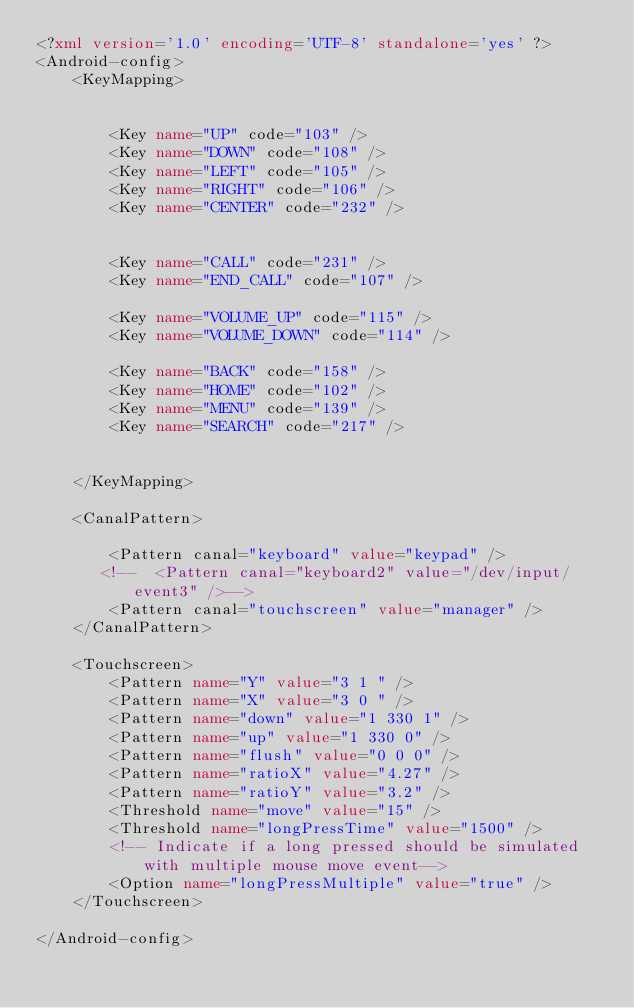<code> <loc_0><loc_0><loc_500><loc_500><_XML_><?xml version='1.0' encoding='UTF-8' standalone='yes' ?>
<Android-config>         
	<KeyMapping>
        
        
        <Key name="UP" code="103" />
        <Key name="DOWN" code="108" />
        <Key name="LEFT" code="105" />
        <Key name="RIGHT" code="106" />
        <Key name="CENTER" code="232" />
    
    
        <Key name="CALL" code="231" />
        <Key name="END_CALL" code="107" />
    
        <Key name="VOLUME_UP" code="115" />
        <Key name="VOLUME_DOWN" code="114" />
        
        <Key name="BACK" code="158" />
        <Key name="HOME" code="102" />
        <Key name="MENU" code="139" />
        <Key name="SEARCH" code="217" />
        
        
	</KeyMapping>

	<CanalPattern>

        <Pattern canal="keyboard" value="keypad" />
       <!--  <Pattern canal="keyboard2" value="/dev/input/event3" />-->
        <Pattern canal="touchscreen" value="manager" />
	</CanalPattern>
        
	<Touchscreen>
        <Pattern name="Y" value="3 1 " />
        <Pattern name="X" value="3 0 " />
        <Pattern name="down" value="1 330 1" />
        <Pattern name="up" value="1 330 0" />
        <Pattern name="flush" value="0 0 0" />
        <Pattern name="ratioX" value="4.27" />
        <Pattern name="ratioY" value="3.2" />
        <Threshold name="move" value="15" />
        <Threshold name="longPressTime" value="1500" />
        <!-- Indicate if a long pressed should be simulated with multiple mouse move event-->
        <Option name="longPressMultiple" value="true" />
	</Touchscreen>

</Android-config></code> 